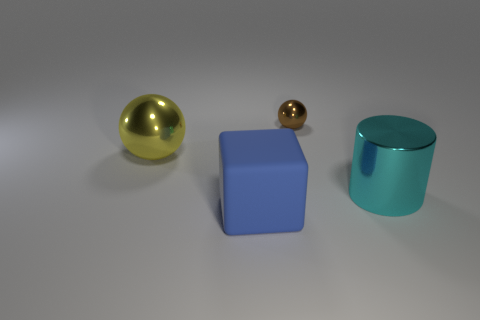Add 4 big red matte spheres. How many objects exist? 8 Subtract all blocks. How many objects are left? 3 Add 2 big green objects. How many big green objects exist? 2 Subtract 0 green cylinders. How many objects are left? 4 Subtract all large rubber things. Subtract all large objects. How many objects are left? 0 Add 3 blue things. How many blue things are left? 4 